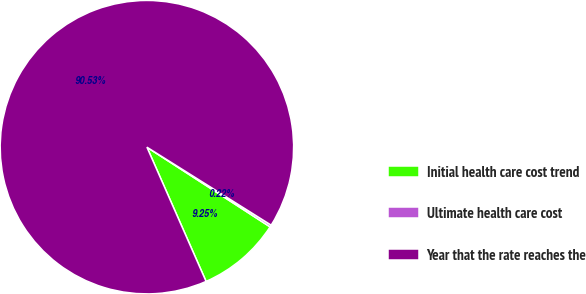Convert chart to OTSL. <chart><loc_0><loc_0><loc_500><loc_500><pie_chart><fcel>Initial health care cost trend<fcel>Ultimate health care cost<fcel>Year that the rate reaches the<nl><fcel>9.25%<fcel>0.22%<fcel>90.52%<nl></chart> 